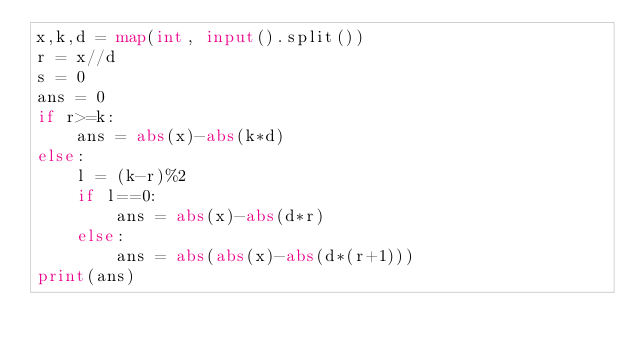<code> <loc_0><loc_0><loc_500><loc_500><_Python_>x,k,d = map(int, input().split())
r = x//d
s = 0
ans = 0
if r>=k:
    ans = abs(x)-abs(k*d)
else:
    l = (k-r)%2
    if l==0:
        ans = abs(x)-abs(d*r)
    else:
        ans = abs(abs(x)-abs(d*(r+1)))
print(ans)</code> 